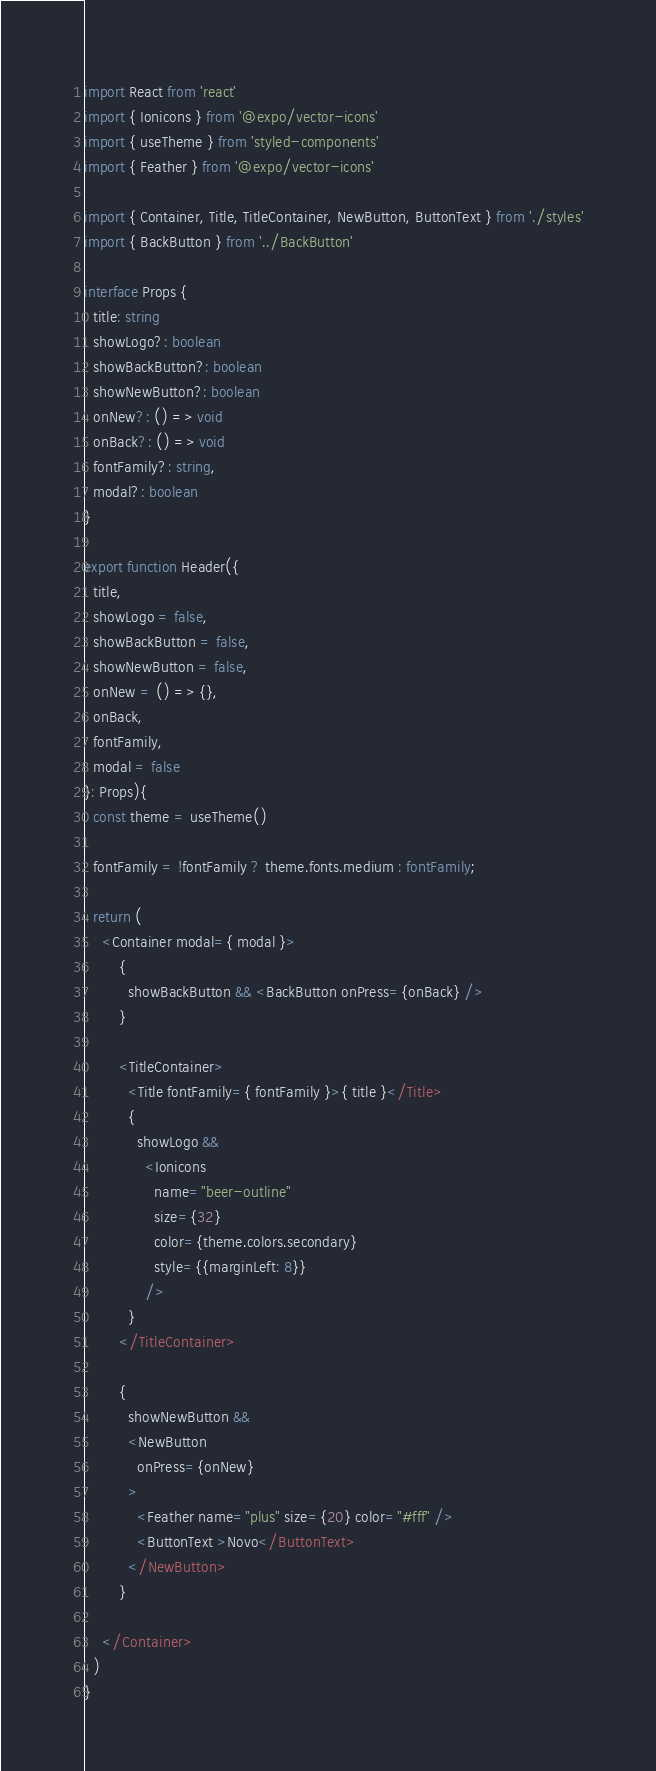<code> <loc_0><loc_0><loc_500><loc_500><_TypeScript_>import React from 'react'
import { Ionicons } from '@expo/vector-icons'
import { useTheme } from 'styled-components'
import { Feather } from '@expo/vector-icons'

import { Container, Title, TitleContainer, NewButton, ButtonText } from './styles'
import { BackButton } from '../BackButton'

interface Props {
  title: string
  showLogo?: boolean
  showBackButton?: boolean
  showNewButton?: boolean
  onNew?: () => void
  onBack?: () => void
  fontFamily?: string,
  modal?: boolean
}

export function Header({ 
  title, 
  showLogo = false, 
  showBackButton = false,
  showNewButton = false,
  onNew = () => {},
  onBack,
  fontFamily,
  modal = false
}: Props){
  const theme = useTheme()

  fontFamily = !fontFamily ? theme.fonts.medium : fontFamily;
  
  return (    
    <Container modal={ modal }>
        {
          showBackButton && <BackButton onPress={onBack} />
        }
          
        <TitleContainer>
          <Title fontFamily={ fontFamily }>{ title }</Title>
          {
            showLogo &&
              <Ionicons 
                name="beer-outline" 
                size={32} 
                color={theme.colors.secondary}
                style={{marginLeft: 8}}
              />
          }
        </TitleContainer>

        {
          showNewButton && 
          <NewButton 
            onPress={onNew} 
          >
            <Feather name="plus" size={20} color="#fff" />
            <ButtonText >Novo</ButtonText>
          </NewButton> 
        }

    </Container>
  )
}</code> 